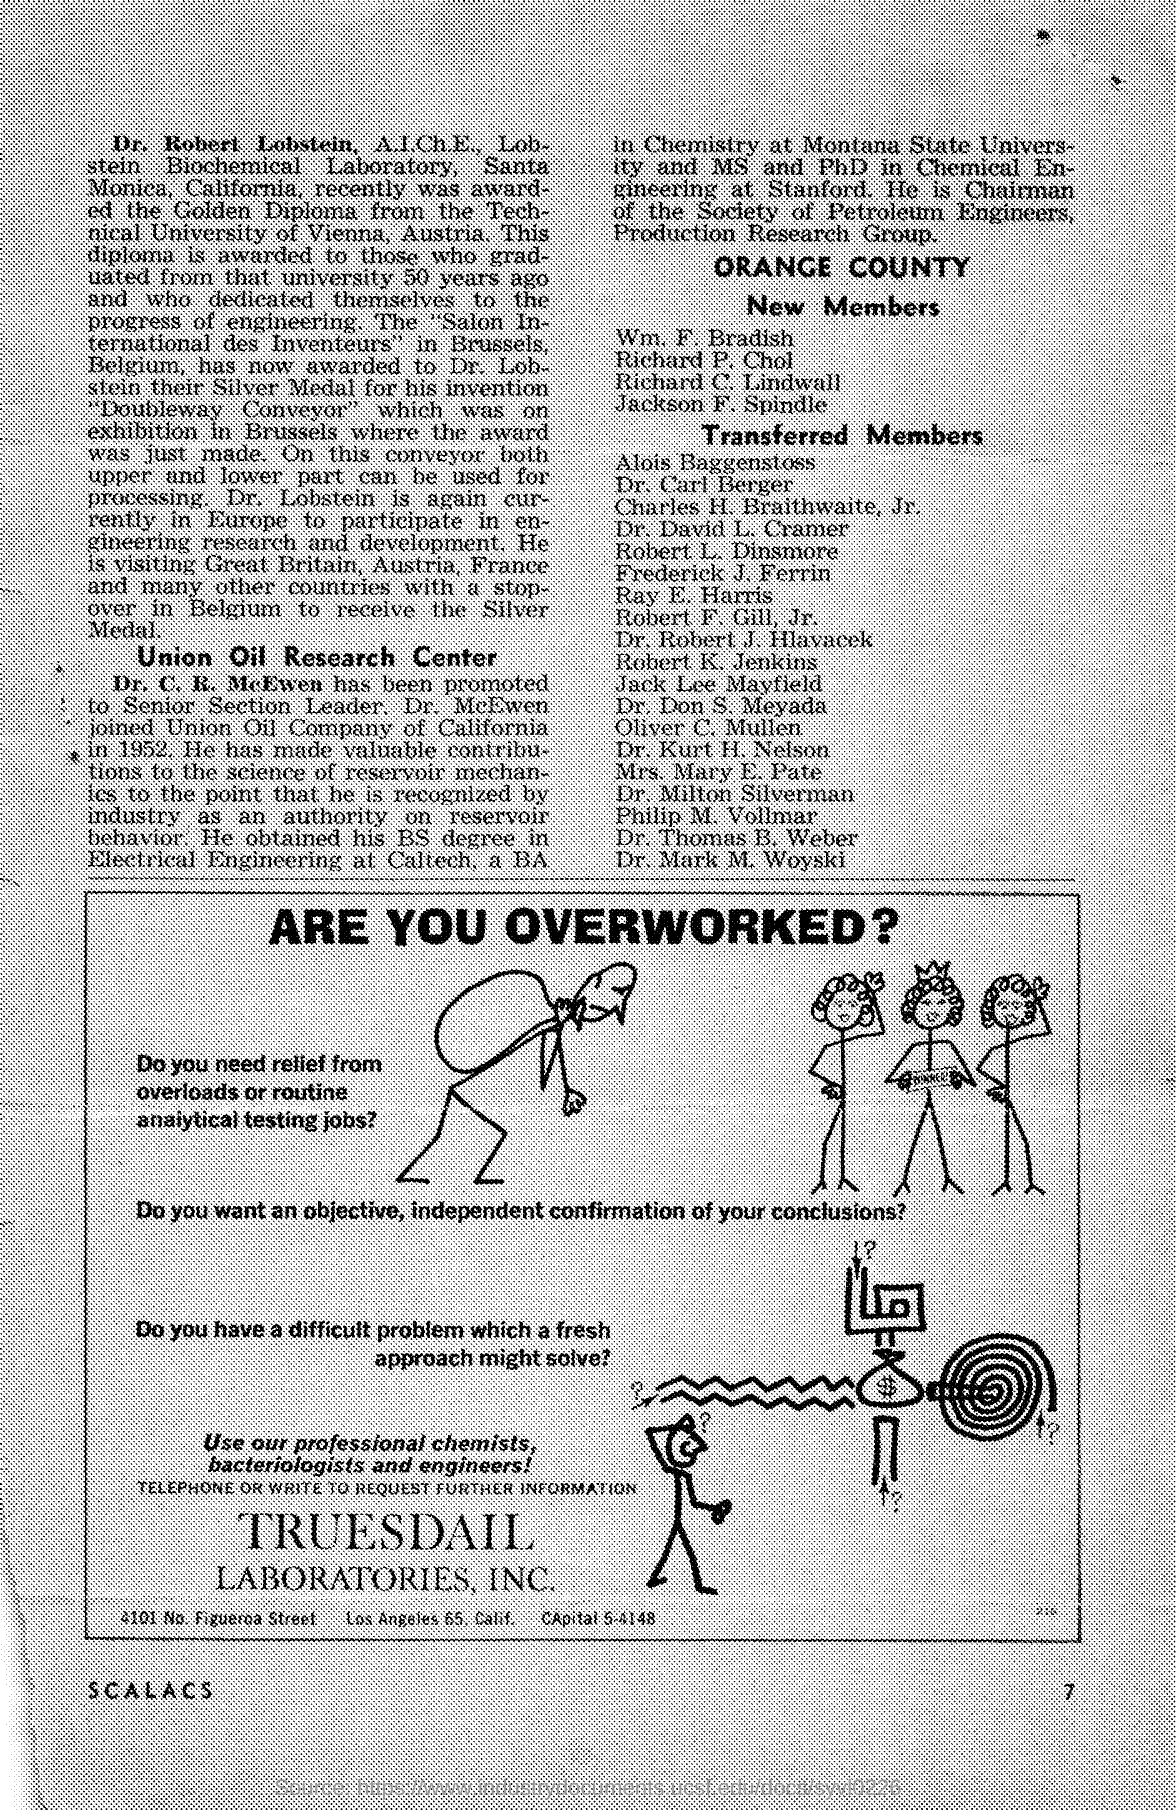What is the name of the laboratories mentioned in the given page ?
Your answer should be compact. Truesdail laboratories ,Inc. In which year dr. mcewen joined union oil company of california ?
Your response must be concise. 1952. 